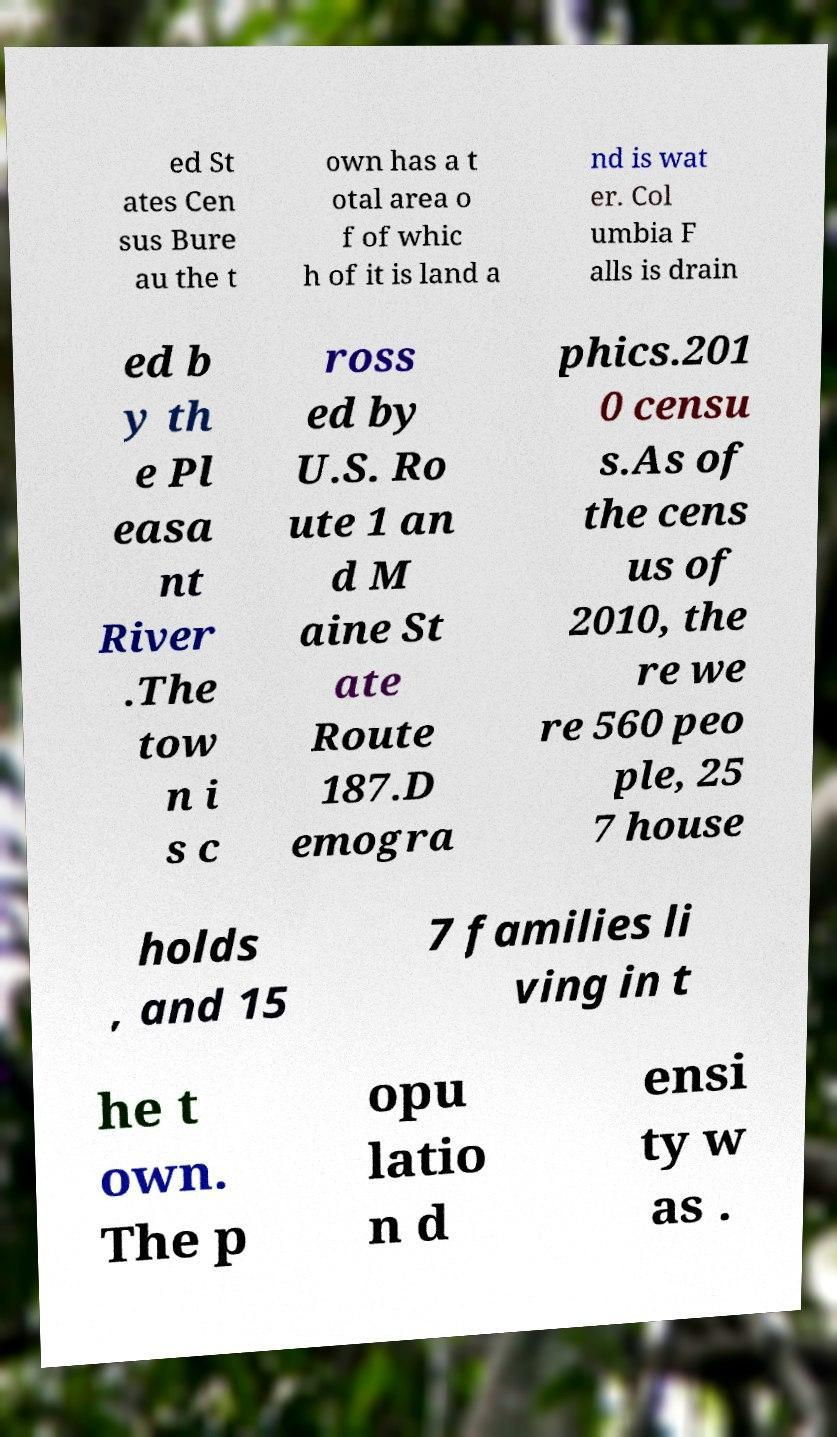Please identify and transcribe the text found in this image. ed St ates Cen sus Bure au the t own has a t otal area o f of whic h of it is land a nd is wat er. Col umbia F alls is drain ed b y th e Pl easa nt River .The tow n i s c ross ed by U.S. Ro ute 1 an d M aine St ate Route 187.D emogra phics.201 0 censu s.As of the cens us of 2010, the re we re 560 peo ple, 25 7 house holds , and 15 7 families li ving in t he t own. The p opu latio n d ensi ty w as . 